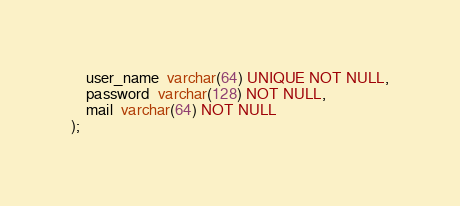<code> <loc_0><loc_0><loc_500><loc_500><_SQL_>    user_name  varchar(64) UNIQUE NOT NULL,
    password  varchar(128) NOT NULL,
    mail  varchar(64) NOT NULL
);
</code> 